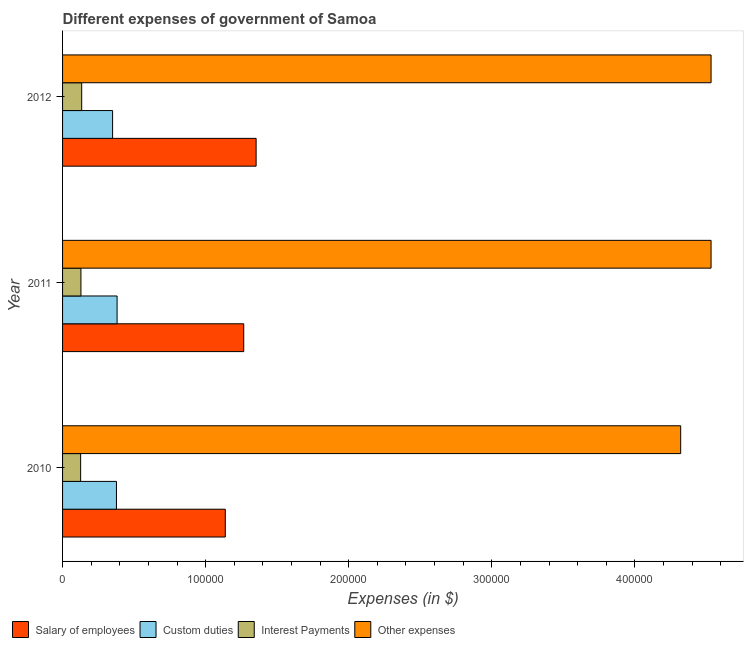How many different coloured bars are there?
Make the answer very short. 4. How many groups of bars are there?
Offer a terse response. 3. Are the number of bars per tick equal to the number of legend labels?
Ensure brevity in your answer.  Yes. What is the amount spent on salary of employees in 2012?
Provide a short and direct response. 1.35e+05. Across all years, what is the maximum amount spent on salary of employees?
Provide a short and direct response. 1.35e+05. Across all years, what is the minimum amount spent on custom duties?
Make the answer very short. 3.50e+04. What is the total amount spent on custom duties in the graph?
Provide a succinct answer. 1.11e+05. What is the difference between the amount spent on salary of employees in 2010 and that in 2011?
Ensure brevity in your answer.  -1.29e+04. What is the difference between the amount spent on interest payments in 2010 and the amount spent on other expenses in 2011?
Ensure brevity in your answer.  -4.41e+05. What is the average amount spent on custom duties per year?
Offer a terse response. 3.69e+04. In the year 2010, what is the difference between the amount spent on salary of employees and amount spent on custom duties?
Your answer should be compact. 7.61e+04. Is the amount spent on custom duties in 2010 less than that in 2011?
Your answer should be very brief. Yes. Is the difference between the amount spent on other expenses in 2010 and 2011 greater than the difference between the amount spent on interest payments in 2010 and 2011?
Your answer should be very brief. No. What is the difference between the highest and the second highest amount spent on other expenses?
Offer a terse response. 5.38. What is the difference between the highest and the lowest amount spent on interest payments?
Your answer should be compact. 732.78. In how many years, is the amount spent on salary of employees greater than the average amount spent on salary of employees taken over all years?
Your answer should be compact. 2. Is the sum of the amount spent on other expenses in 2010 and 2011 greater than the maximum amount spent on salary of employees across all years?
Give a very brief answer. Yes. What does the 3rd bar from the top in 2012 represents?
Make the answer very short. Custom duties. What does the 2nd bar from the bottom in 2010 represents?
Provide a succinct answer. Custom duties. Is it the case that in every year, the sum of the amount spent on salary of employees and amount spent on custom duties is greater than the amount spent on interest payments?
Your answer should be very brief. Yes. How many bars are there?
Keep it short and to the point. 12. Are all the bars in the graph horizontal?
Your answer should be compact. Yes. How many years are there in the graph?
Give a very brief answer. 3. Does the graph contain grids?
Provide a short and direct response. No. What is the title of the graph?
Your answer should be very brief. Different expenses of government of Samoa. What is the label or title of the X-axis?
Give a very brief answer. Expenses (in $). What is the Expenses (in $) in Salary of employees in 2010?
Your answer should be very brief. 1.14e+05. What is the Expenses (in $) of Custom duties in 2010?
Ensure brevity in your answer.  3.77e+04. What is the Expenses (in $) of Interest Payments in 2010?
Provide a succinct answer. 1.26e+04. What is the Expenses (in $) in Other expenses in 2010?
Offer a terse response. 4.32e+05. What is the Expenses (in $) in Salary of employees in 2011?
Provide a succinct answer. 1.27e+05. What is the Expenses (in $) in Custom duties in 2011?
Your answer should be very brief. 3.81e+04. What is the Expenses (in $) of Interest Payments in 2011?
Your answer should be very brief. 1.28e+04. What is the Expenses (in $) in Other expenses in 2011?
Keep it short and to the point. 4.53e+05. What is the Expenses (in $) of Salary of employees in 2012?
Ensure brevity in your answer.  1.35e+05. What is the Expenses (in $) in Custom duties in 2012?
Give a very brief answer. 3.50e+04. What is the Expenses (in $) of Interest Payments in 2012?
Provide a short and direct response. 1.34e+04. What is the Expenses (in $) in Other expenses in 2012?
Give a very brief answer. 4.53e+05. Across all years, what is the maximum Expenses (in $) of Salary of employees?
Make the answer very short. 1.35e+05. Across all years, what is the maximum Expenses (in $) of Custom duties?
Provide a short and direct response. 3.81e+04. Across all years, what is the maximum Expenses (in $) in Interest Payments?
Make the answer very short. 1.34e+04. Across all years, what is the maximum Expenses (in $) of Other expenses?
Your response must be concise. 4.53e+05. Across all years, what is the minimum Expenses (in $) in Salary of employees?
Your response must be concise. 1.14e+05. Across all years, what is the minimum Expenses (in $) in Custom duties?
Your answer should be compact. 3.50e+04. Across all years, what is the minimum Expenses (in $) in Interest Payments?
Give a very brief answer. 1.26e+04. Across all years, what is the minimum Expenses (in $) in Other expenses?
Your answer should be very brief. 4.32e+05. What is the total Expenses (in $) of Salary of employees in the graph?
Offer a very short reply. 3.76e+05. What is the total Expenses (in $) in Custom duties in the graph?
Your answer should be compact. 1.11e+05. What is the total Expenses (in $) of Interest Payments in the graph?
Provide a succinct answer. 3.88e+04. What is the total Expenses (in $) in Other expenses in the graph?
Ensure brevity in your answer.  1.34e+06. What is the difference between the Expenses (in $) of Salary of employees in 2010 and that in 2011?
Your answer should be compact. -1.29e+04. What is the difference between the Expenses (in $) of Custom duties in 2010 and that in 2011?
Your answer should be compact. -446.14. What is the difference between the Expenses (in $) in Interest Payments in 2010 and that in 2011?
Your answer should be very brief. -201.28. What is the difference between the Expenses (in $) of Other expenses in 2010 and that in 2011?
Offer a terse response. -2.12e+04. What is the difference between the Expenses (in $) in Salary of employees in 2010 and that in 2012?
Your answer should be compact. -2.16e+04. What is the difference between the Expenses (in $) of Custom duties in 2010 and that in 2012?
Your answer should be compact. 2691.4. What is the difference between the Expenses (in $) in Interest Payments in 2010 and that in 2012?
Provide a short and direct response. -732.78. What is the difference between the Expenses (in $) in Other expenses in 2010 and that in 2012?
Your answer should be compact. -2.12e+04. What is the difference between the Expenses (in $) in Salary of employees in 2011 and that in 2012?
Keep it short and to the point. -8666.97. What is the difference between the Expenses (in $) in Custom duties in 2011 and that in 2012?
Your answer should be very brief. 3137.54. What is the difference between the Expenses (in $) in Interest Payments in 2011 and that in 2012?
Offer a very short reply. -531.5. What is the difference between the Expenses (in $) of Other expenses in 2011 and that in 2012?
Provide a short and direct response. -5.38. What is the difference between the Expenses (in $) of Salary of employees in 2010 and the Expenses (in $) of Custom duties in 2011?
Make the answer very short. 7.56e+04. What is the difference between the Expenses (in $) of Salary of employees in 2010 and the Expenses (in $) of Interest Payments in 2011?
Your answer should be very brief. 1.01e+05. What is the difference between the Expenses (in $) of Salary of employees in 2010 and the Expenses (in $) of Other expenses in 2011?
Make the answer very short. -3.40e+05. What is the difference between the Expenses (in $) in Custom duties in 2010 and the Expenses (in $) in Interest Payments in 2011?
Make the answer very short. 2.48e+04. What is the difference between the Expenses (in $) in Custom duties in 2010 and the Expenses (in $) in Other expenses in 2011?
Ensure brevity in your answer.  -4.16e+05. What is the difference between the Expenses (in $) of Interest Payments in 2010 and the Expenses (in $) of Other expenses in 2011?
Offer a terse response. -4.41e+05. What is the difference between the Expenses (in $) in Salary of employees in 2010 and the Expenses (in $) in Custom duties in 2012?
Your answer should be very brief. 7.88e+04. What is the difference between the Expenses (in $) of Salary of employees in 2010 and the Expenses (in $) of Interest Payments in 2012?
Keep it short and to the point. 1.00e+05. What is the difference between the Expenses (in $) of Salary of employees in 2010 and the Expenses (in $) of Other expenses in 2012?
Keep it short and to the point. -3.40e+05. What is the difference between the Expenses (in $) in Custom duties in 2010 and the Expenses (in $) in Interest Payments in 2012?
Ensure brevity in your answer.  2.43e+04. What is the difference between the Expenses (in $) of Custom duties in 2010 and the Expenses (in $) of Other expenses in 2012?
Your response must be concise. -4.16e+05. What is the difference between the Expenses (in $) in Interest Payments in 2010 and the Expenses (in $) in Other expenses in 2012?
Your answer should be very brief. -4.41e+05. What is the difference between the Expenses (in $) in Salary of employees in 2011 and the Expenses (in $) in Custom duties in 2012?
Your response must be concise. 9.17e+04. What is the difference between the Expenses (in $) of Salary of employees in 2011 and the Expenses (in $) of Interest Payments in 2012?
Offer a terse response. 1.13e+05. What is the difference between the Expenses (in $) in Salary of employees in 2011 and the Expenses (in $) in Other expenses in 2012?
Your answer should be very brief. -3.27e+05. What is the difference between the Expenses (in $) of Custom duties in 2011 and the Expenses (in $) of Interest Payments in 2012?
Your answer should be very brief. 2.47e+04. What is the difference between the Expenses (in $) of Custom duties in 2011 and the Expenses (in $) of Other expenses in 2012?
Your answer should be compact. -4.15e+05. What is the difference between the Expenses (in $) in Interest Payments in 2011 and the Expenses (in $) in Other expenses in 2012?
Provide a succinct answer. -4.40e+05. What is the average Expenses (in $) in Salary of employees per year?
Your answer should be compact. 1.25e+05. What is the average Expenses (in $) of Custom duties per year?
Give a very brief answer. 3.69e+04. What is the average Expenses (in $) of Interest Payments per year?
Provide a short and direct response. 1.29e+04. What is the average Expenses (in $) of Other expenses per year?
Your answer should be very brief. 4.46e+05. In the year 2010, what is the difference between the Expenses (in $) of Salary of employees and Expenses (in $) of Custom duties?
Provide a short and direct response. 7.61e+04. In the year 2010, what is the difference between the Expenses (in $) in Salary of employees and Expenses (in $) in Interest Payments?
Offer a very short reply. 1.01e+05. In the year 2010, what is the difference between the Expenses (in $) of Salary of employees and Expenses (in $) of Other expenses?
Make the answer very short. -3.18e+05. In the year 2010, what is the difference between the Expenses (in $) of Custom duties and Expenses (in $) of Interest Payments?
Ensure brevity in your answer.  2.50e+04. In the year 2010, what is the difference between the Expenses (in $) in Custom duties and Expenses (in $) in Other expenses?
Provide a succinct answer. -3.94e+05. In the year 2010, what is the difference between the Expenses (in $) in Interest Payments and Expenses (in $) in Other expenses?
Offer a terse response. -4.19e+05. In the year 2011, what is the difference between the Expenses (in $) in Salary of employees and Expenses (in $) in Custom duties?
Make the answer very short. 8.85e+04. In the year 2011, what is the difference between the Expenses (in $) in Salary of employees and Expenses (in $) in Interest Payments?
Provide a succinct answer. 1.14e+05. In the year 2011, what is the difference between the Expenses (in $) in Salary of employees and Expenses (in $) in Other expenses?
Provide a short and direct response. -3.27e+05. In the year 2011, what is the difference between the Expenses (in $) of Custom duties and Expenses (in $) of Interest Payments?
Your answer should be compact. 2.53e+04. In the year 2011, what is the difference between the Expenses (in $) of Custom duties and Expenses (in $) of Other expenses?
Provide a succinct answer. -4.15e+05. In the year 2011, what is the difference between the Expenses (in $) in Interest Payments and Expenses (in $) in Other expenses?
Provide a short and direct response. -4.40e+05. In the year 2012, what is the difference between the Expenses (in $) in Salary of employees and Expenses (in $) in Custom duties?
Provide a succinct answer. 1.00e+05. In the year 2012, what is the difference between the Expenses (in $) of Salary of employees and Expenses (in $) of Interest Payments?
Give a very brief answer. 1.22e+05. In the year 2012, what is the difference between the Expenses (in $) in Salary of employees and Expenses (in $) in Other expenses?
Offer a very short reply. -3.18e+05. In the year 2012, what is the difference between the Expenses (in $) of Custom duties and Expenses (in $) of Interest Payments?
Your answer should be compact. 2.16e+04. In the year 2012, what is the difference between the Expenses (in $) of Custom duties and Expenses (in $) of Other expenses?
Provide a succinct answer. -4.18e+05. In the year 2012, what is the difference between the Expenses (in $) in Interest Payments and Expenses (in $) in Other expenses?
Offer a very short reply. -4.40e+05. What is the ratio of the Expenses (in $) of Salary of employees in 2010 to that in 2011?
Offer a terse response. 0.9. What is the ratio of the Expenses (in $) of Custom duties in 2010 to that in 2011?
Your answer should be very brief. 0.99. What is the ratio of the Expenses (in $) of Interest Payments in 2010 to that in 2011?
Give a very brief answer. 0.98. What is the ratio of the Expenses (in $) of Other expenses in 2010 to that in 2011?
Keep it short and to the point. 0.95. What is the ratio of the Expenses (in $) of Salary of employees in 2010 to that in 2012?
Your answer should be compact. 0.84. What is the ratio of the Expenses (in $) in Custom duties in 2010 to that in 2012?
Keep it short and to the point. 1.08. What is the ratio of the Expenses (in $) in Interest Payments in 2010 to that in 2012?
Your answer should be compact. 0.95. What is the ratio of the Expenses (in $) in Other expenses in 2010 to that in 2012?
Make the answer very short. 0.95. What is the ratio of the Expenses (in $) in Salary of employees in 2011 to that in 2012?
Your answer should be compact. 0.94. What is the ratio of the Expenses (in $) of Custom duties in 2011 to that in 2012?
Offer a terse response. 1.09. What is the ratio of the Expenses (in $) in Interest Payments in 2011 to that in 2012?
Ensure brevity in your answer.  0.96. What is the ratio of the Expenses (in $) of Other expenses in 2011 to that in 2012?
Offer a very short reply. 1. What is the difference between the highest and the second highest Expenses (in $) of Salary of employees?
Provide a succinct answer. 8666.97. What is the difference between the highest and the second highest Expenses (in $) in Custom duties?
Provide a short and direct response. 446.14. What is the difference between the highest and the second highest Expenses (in $) of Interest Payments?
Your response must be concise. 531.5. What is the difference between the highest and the second highest Expenses (in $) of Other expenses?
Offer a very short reply. 5.38. What is the difference between the highest and the lowest Expenses (in $) in Salary of employees?
Your answer should be very brief. 2.16e+04. What is the difference between the highest and the lowest Expenses (in $) of Custom duties?
Your answer should be compact. 3137.54. What is the difference between the highest and the lowest Expenses (in $) in Interest Payments?
Make the answer very short. 732.78. What is the difference between the highest and the lowest Expenses (in $) of Other expenses?
Your answer should be compact. 2.12e+04. 